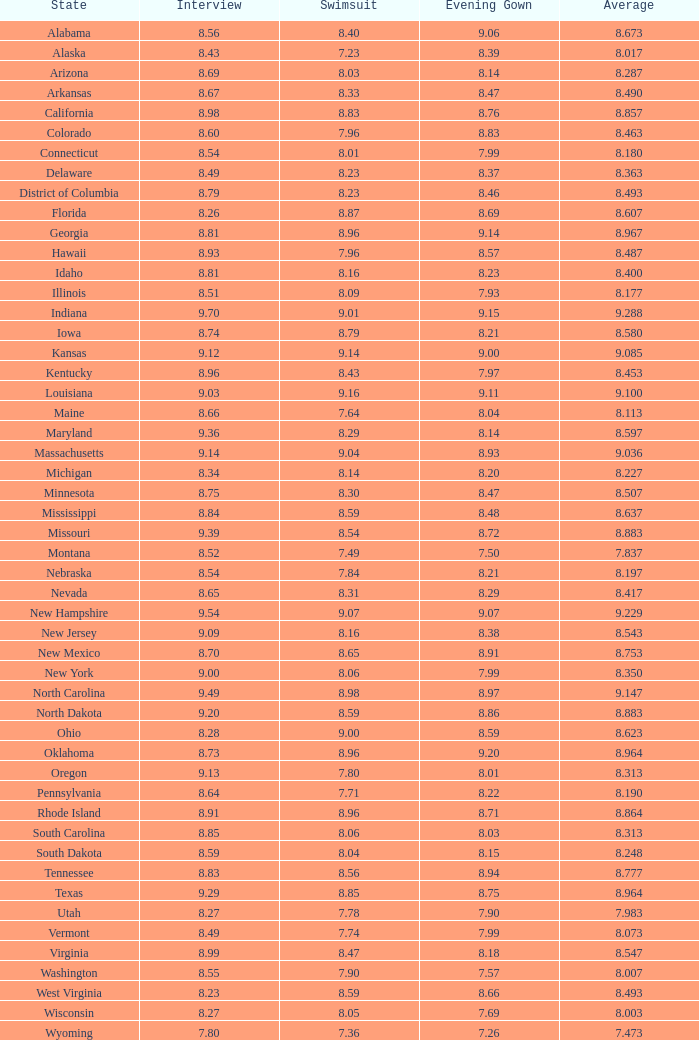86 and dialogue less than Alabama. 